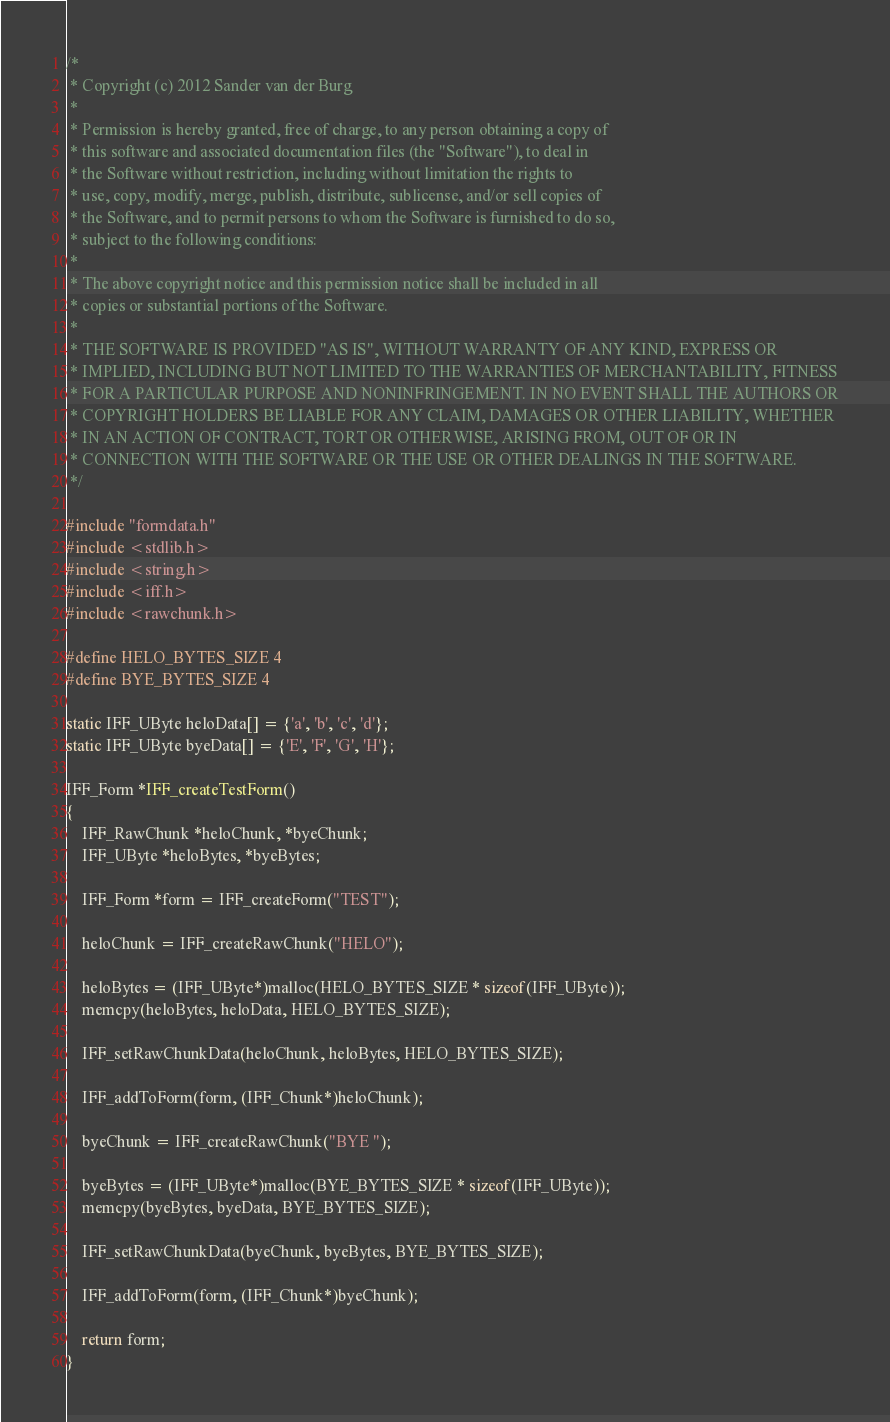<code> <loc_0><loc_0><loc_500><loc_500><_C_>/*
 * Copyright (c) 2012 Sander van der Burg
 *
 * Permission is hereby granted, free of charge, to any person obtaining a copy of
 * this software and associated documentation files (the "Software"), to deal in
 * the Software without restriction, including without limitation the rights to
 * use, copy, modify, merge, publish, distribute, sublicense, and/or sell copies of
 * the Software, and to permit persons to whom the Software is furnished to do so, 
 * subject to the following conditions:
 *
 * The above copyright notice and this permission notice shall be included in all
 * copies or substantial portions of the Software.
 *
 * THE SOFTWARE IS PROVIDED "AS IS", WITHOUT WARRANTY OF ANY KIND, EXPRESS OR
 * IMPLIED, INCLUDING BUT NOT LIMITED TO THE WARRANTIES OF MERCHANTABILITY, FITNESS
 * FOR A PARTICULAR PURPOSE AND NONINFRINGEMENT. IN NO EVENT SHALL THE AUTHORS OR
 * COPYRIGHT HOLDERS BE LIABLE FOR ANY CLAIM, DAMAGES OR OTHER LIABILITY, WHETHER
 * IN AN ACTION OF CONTRACT, TORT OR OTHERWISE, ARISING FROM, OUT OF OR IN
 * CONNECTION WITH THE SOFTWARE OR THE USE OR OTHER DEALINGS IN THE SOFTWARE.
 */

#include "formdata.h"
#include <stdlib.h>
#include <string.h>
#include <iff.h>
#include <rawchunk.h>

#define HELO_BYTES_SIZE 4
#define BYE_BYTES_SIZE 4

static IFF_UByte heloData[] = {'a', 'b', 'c', 'd'};
static IFF_UByte byeData[] = {'E', 'F', 'G', 'H'};

IFF_Form *IFF_createTestForm()
{
    IFF_RawChunk *heloChunk, *byeChunk;
    IFF_UByte *heloBytes, *byeBytes;
    
    IFF_Form *form = IFF_createForm("TEST");
    
    heloChunk = IFF_createRawChunk("HELO");
    
    heloBytes = (IFF_UByte*)malloc(HELO_BYTES_SIZE * sizeof(IFF_UByte));
    memcpy(heloBytes, heloData, HELO_BYTES_SIZE);

    IFF_setRawChunkData(heloChunk, heloBytes, HELO_BYTES_SIZE);
    
    IFF_addToForm(form, (IFF_Chunk*)heloChunk);
    
    byeChunk = IFF_createRawChunk("BYE ");
    
    byeBytes = (IFF_UByte*)malloc(BYE_BYTES_SIZE * sizeof(IFF_UByte));
    memcpy(byeBytes, byeData, BYE_BYTES_SIZE);
    
    IFF_setRawChunkData(byeChunk, byeBytes, BYE_BYTES_SIZE);
    
    IFF_addToForm(form, (IFF_Chunk*)byeChunk);
    
    return form;
}
</code> 